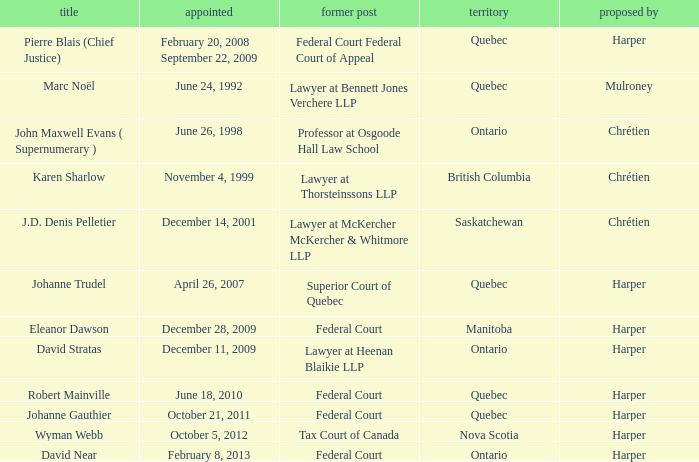What was the prior position held by Wyman Webb? Tax Court of Canada. Help me parse the entirety of this table. {'header': ['title', 'appointed', 'former post', 'territory', 'proposed by'], 'rows': [['Pierre Blais (Chief Justice)', 'February 20, 2008 September 22, 2009', 'Federal Court Federal Court of Appeal', 'Quebec', 'Harper'], ['Marc Noël', 'June 24, 1992', 'Lawyer at Bennett Jones Verchere LLP', 'Quebec', 'Mulroney'], ['John Maxwell Evans ( Supernumerary )', 'June 26, 1998', 'Professor at Osgoode Hall Law School', 'Ontario', 'Chrétien'], ['Karen Sharlow', 'November 4, 1999', 'Lawyer at Thorsteinssons LLP', 'British Columbia', 'Chrétien'], ['J.D. Denis Pelletier', 'December 14, 2001', 'Lawyer at McKercher McKercher & Whitmore LLP', 'Saskatchewan', 'Chrétien'], ['Johanne Trudel', 'April 26, 2007', 'Superior Court of Quebec', 'Quebec', 'Harper'], ['Eleanor Dawson', 'December 28, 2009', 'Federal Court', 'Manitoba', 'Harper'], ['David Stratas', 'December 11, 2009', 'Lawyer at Heenan Blaikie LLP', 'Ontario', 'Harper'], ['Robert Mainville', 'June 18, 2010', 'Federal Court', 'Quebec', 'Harper'], ['Johanne Gauthier', 'October 21, 2011', 'Federal Court', 'Quebec', 'Harper'], ['Wyman Webb', 'October 5, 2012', 'Tax Court of Canada', 'Nova Scotia', 'Harper'], ['David Near', 'February 8, 2013', 'Federal Court', 'Ontario', 'Harper']]} 